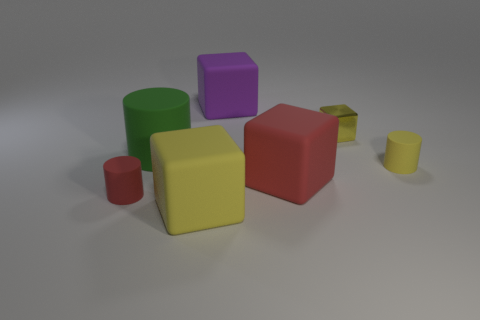Are there any tiny yellow metal things?
Offer a very short reply. Yes. How many other objects are there of the same material as the small yellow cylinder?
Make the answer very short. 5. What is the material of the yellow block that is the same size as the red matte cube?
Offer a very short reply. Rubber. Do the yellow rubber thing that is behind the large red matte object and the purple object have the same shape?
Provide a succinct answer. No. Is the color of the large cylinder the same as the metal block?
Your response must be concise. No. What number of objects are rubber cubes behind the big red object or large yellow things?
Your response must be concise. 2. There is a yellow rubber object that is the same size as the shiny object; what shape is it?
Provide a succinct answer. Cylinder. Is the size of the purple rubber block that is behind the big yellow object the same as the matte object left of the big matte cylinder?
Ensure brevity in your answer.  No. What color is the large cylinder that is made of the same material as the purple thing?
Give a very brief answer. Green. Do the cylinder that is to the left of the green rubber object and the small cylinder to the right of the metallic thing have the same material?
Provide a succinct answer. Yes. 